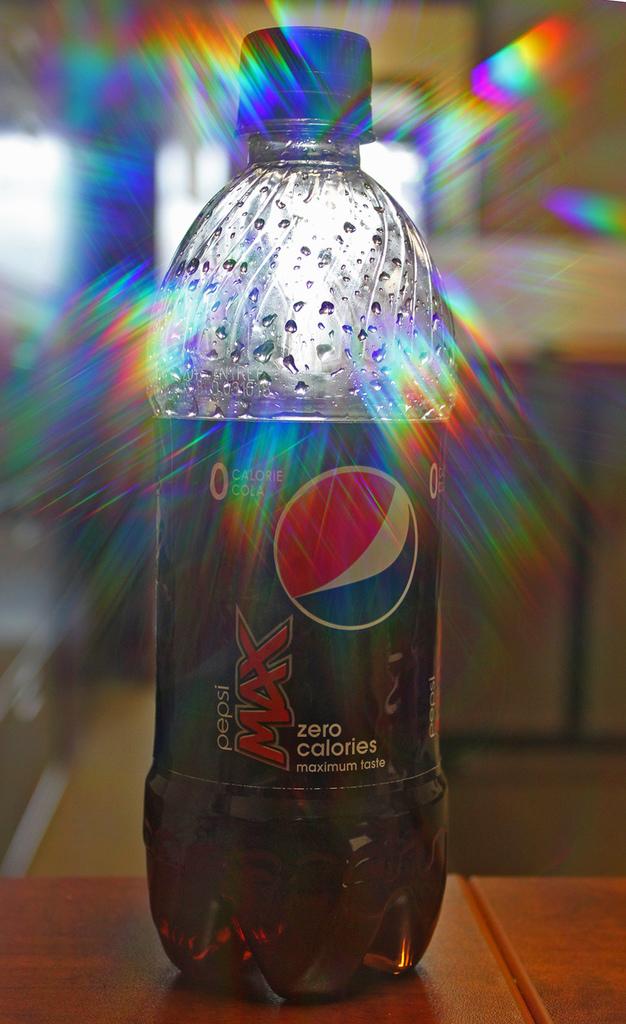What is the brand of this soda?
Give a very brief answer. Pepsi. How many calories in this beverage?
Ensure brevity in your answer.  Zero. 